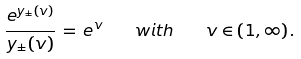<formula> <loc_0><loc_0><loc_500><loc_500>\frac { e ^ { y _ { \pm } ( v ) } } { y _ { \pm } ( v ) } \, = \, e ^ { v } \quad w i t h \quad v \in ( 1 , \infty ) \, .</formula> 